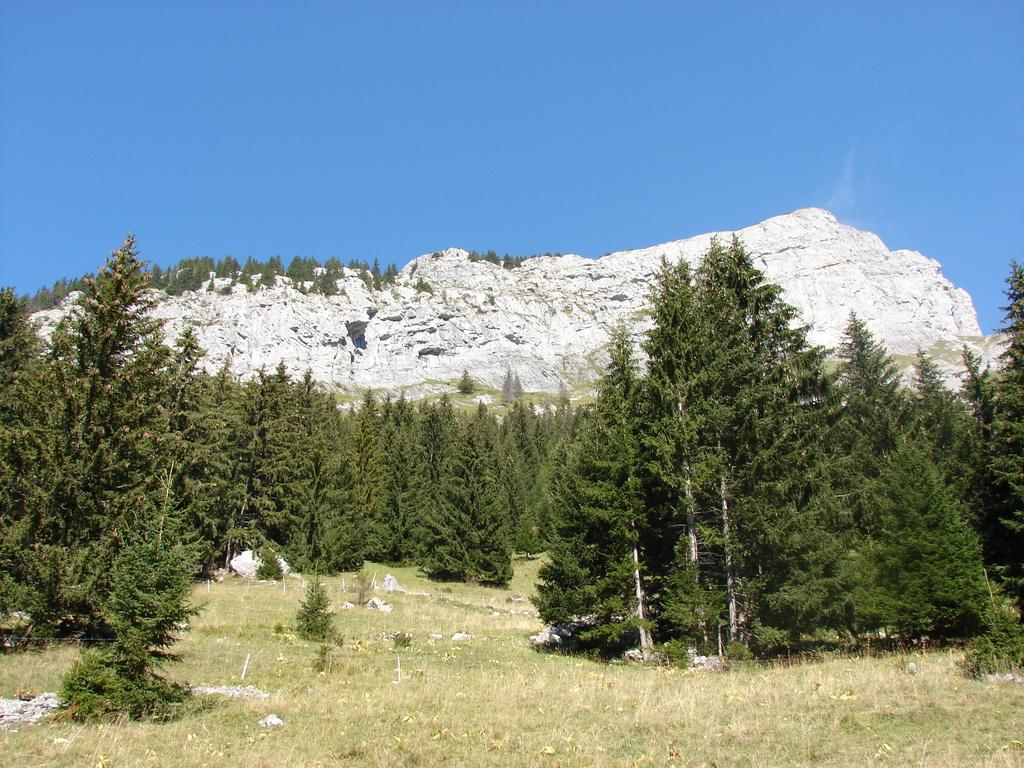What type of vegetation is present in the image? There are trees in the image. What type of ground cover is present in the image? There is grass in the image. What type of geographical feature is present in the image? There are mountains in the image. What part of the natural environment is visible in the image? The sky is visible in the image. What type of income can be seen in the image? There is no reference to income in the image; it features trees, grass, mountains, and the sky. Where is the nest located in the image? There is no nest present in the image. 